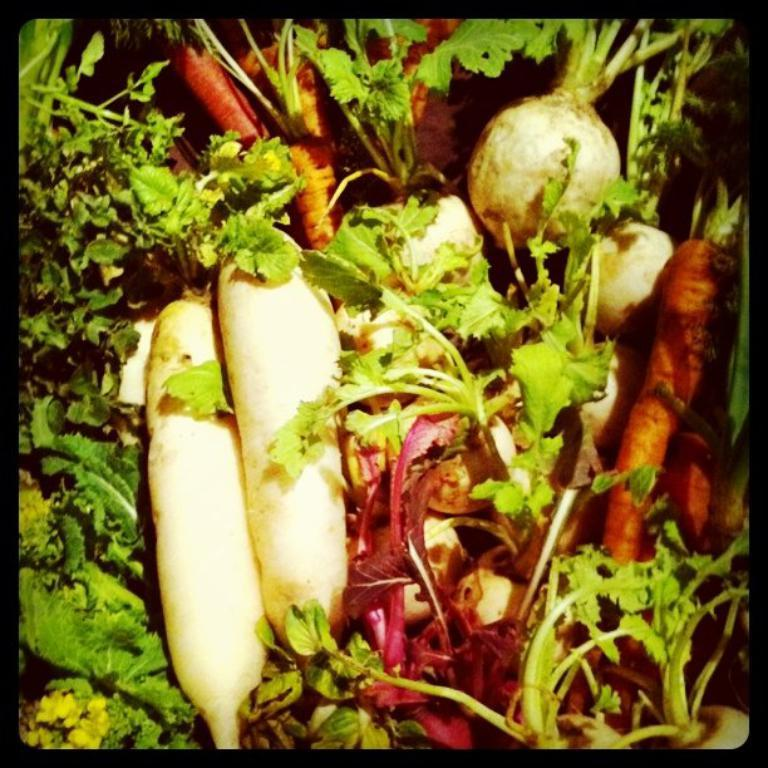What types of food items are present in the image? There are many vegetables in the image. Can you describe the colors of the vegetables in the image? The vegetables have various colors, including green, pink, orange, and cream. What type of whip can be seen in the image? There is no whip present in the image; it features various vegetables with different colors. 